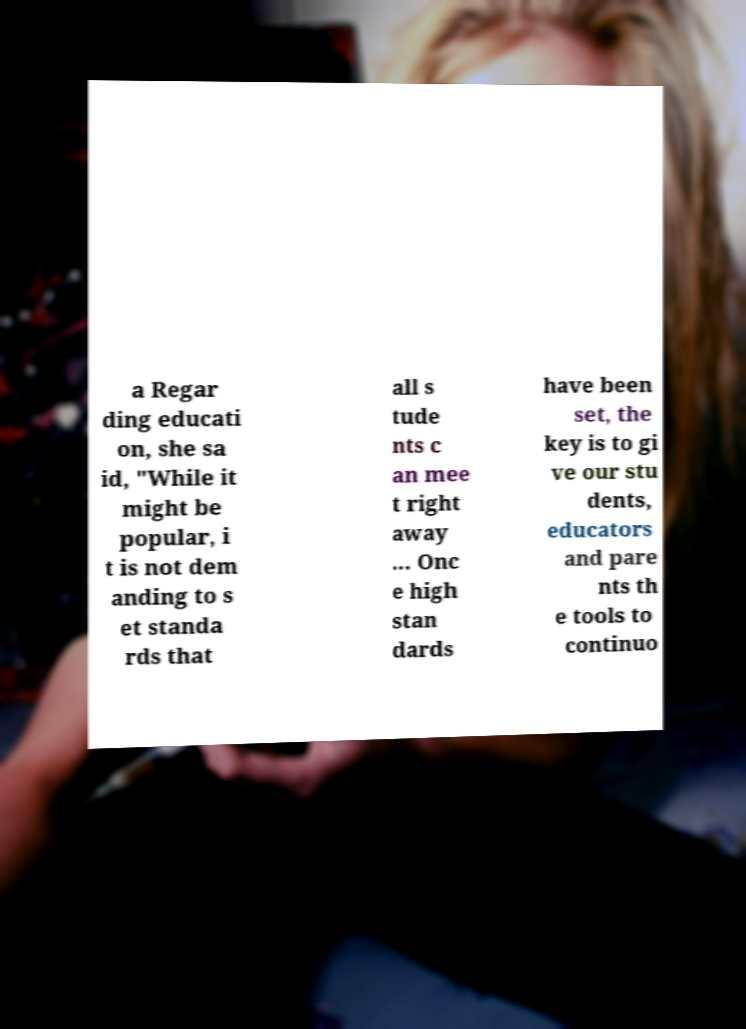Could you extract and type out the text from this image? a Regar ding educati on, she sa id, "While it might be popular, i t is not dem anding to s et standa rds that all s tude nts c an mee t right away ... Onc e high stan dards have been set, the key is to gi ve our stu dents, educators and pare nts th e tools to continuo 